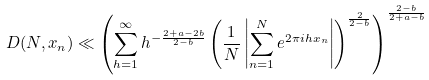<formula> <loc_0><loc_0><loc_500><loc_500>D ( N , x _ { n } ) \ll \left ( \sum _ { h = 1 } ^ { \infty } h ^ { - \frac { 2 + a - 2 b } { 2 - b } } \left ( \frac { 1 } { N } \left | \sum _ { n = 1 } ^ { N } e ^ { 2 \pi i h x _ { n } } \right | \right ) ^ { \frac { 2 } { 2 - b } } \right ) ^ { \frac { 2 - b } { 2 + a - b } }</formula> 